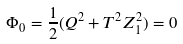Convert formula to latex. <formula><loc_0><loc_0><loc_500><loc_500>\Phi _ { 0 } = \frac { 1 } { 2 } ( Q ^ { 2 } + T ^ { 2 } Z _ { 1 } ^ { 2 } ) = 0</formula> 